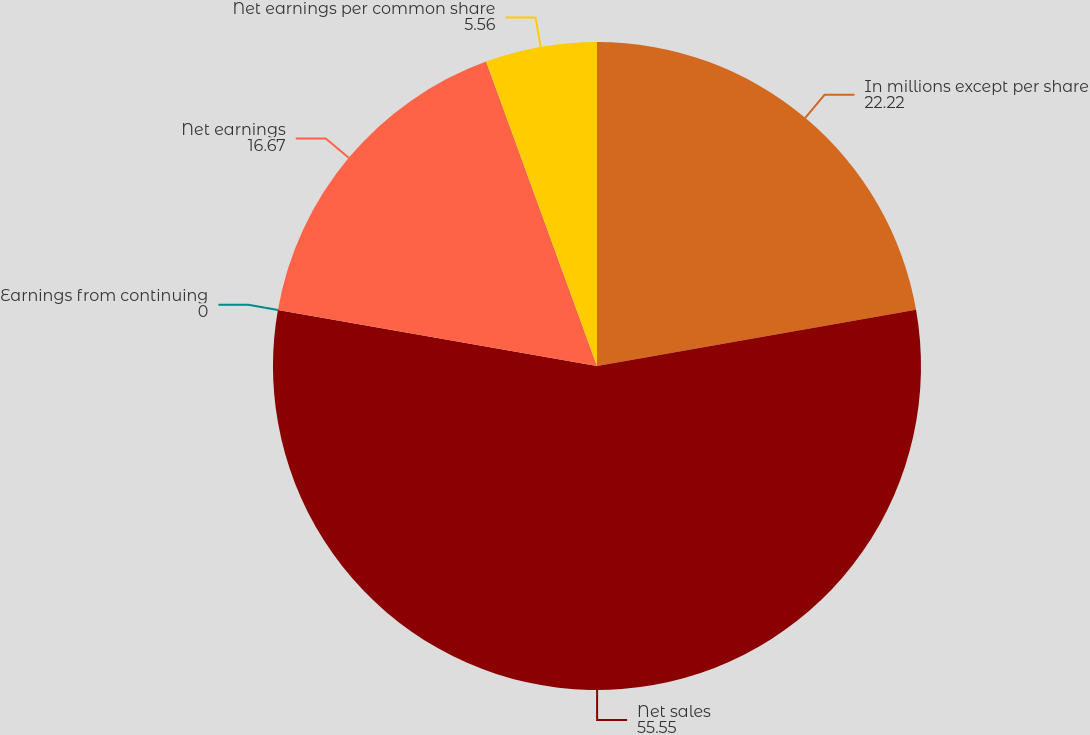Convert chart to OTSL. <chart><loc_0><loc_0><loc_500><loc_500><pie_chart><fcel>In millions except per share<fcel>Net sales<fcel>Earnings from continuing<fcel>Net earnings<fcel>Net earnings per common share<nl><fcel>22.22%<fcel>55.55%<fcel>0.0%<fcel>16.67%<fcel>5.56%<nl></chart> 